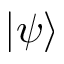Convert formula to latex. <formula><loc_0><loc_0><loc_500><loc_500>| \psi \rangle</formula> 